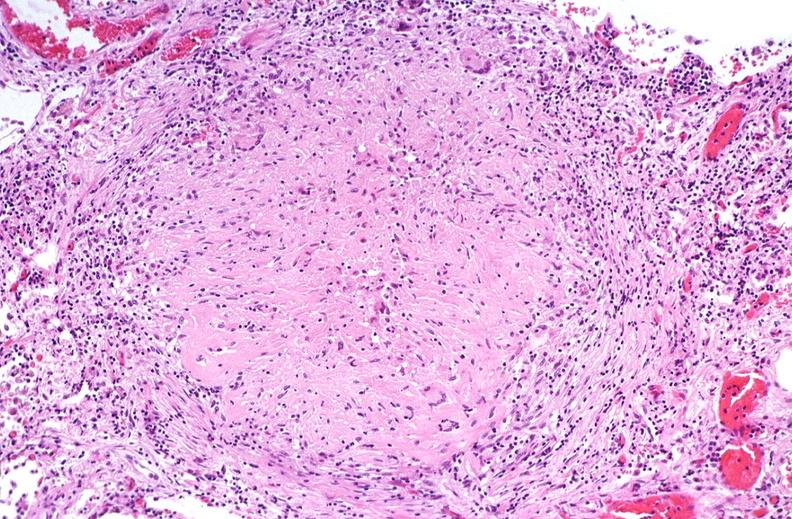s respiratory present?
Answer the question using a single word or phrase. Yes 